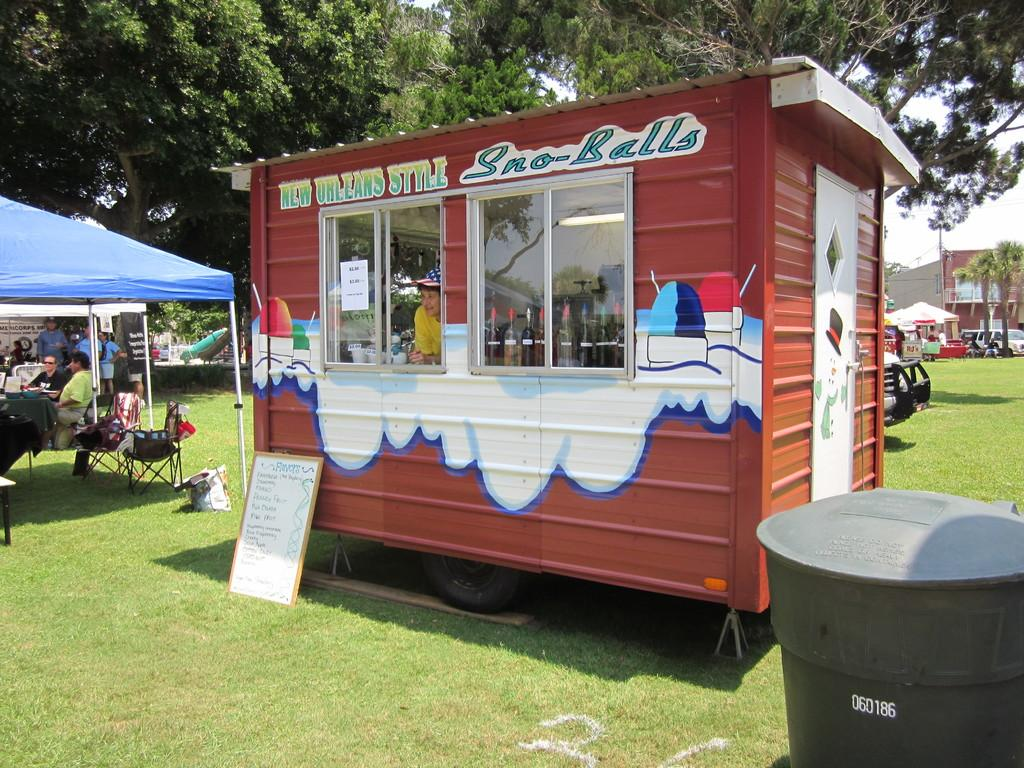<image>
Provide a brief description of the given image. A food stand called Sno-Bells in a small brown container. 